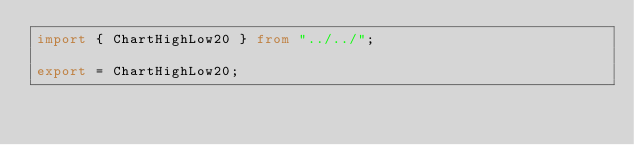<code> <loc_0><loc_0><loc_500><loc_500><_TypeScript_>import { ChartHighLow20 } from "../../";

export = ChartHighLow20;
</code> 